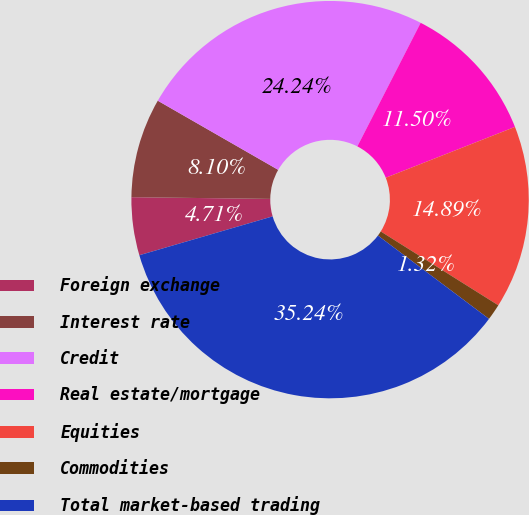Convert chart. <chart><loc_0><loc_0><loc_500><loc_500><pie_chart><fcel>Foreign exchange<fcel>Interest rate<fcel>Credit<fcel>Real estate/mortgage<fcel>Equities<fcel>Commodities<fcel>Total market-based trading<nl><fcel>4.71%<fcel>8.1%<fcel>24.24%<fcel>11.5%<fcel>14.89%<fcel>1.32%<fcel>35.24%<nl></chart> 